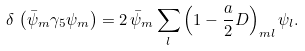Convert formula to latex. <formula><loc_0><loc_0><loc_500><loc_500>\delta \, \left ( \bar { \psi } _ { m } \gamma _ { 5 } \psi _ { m } \right ) = 2 \, \bar { \psi } _ { m } \sum _ { l } \left ( 1 - \frac { a } { 2 } D \right ) _ { m l } \psi _ { l } .</formula> 